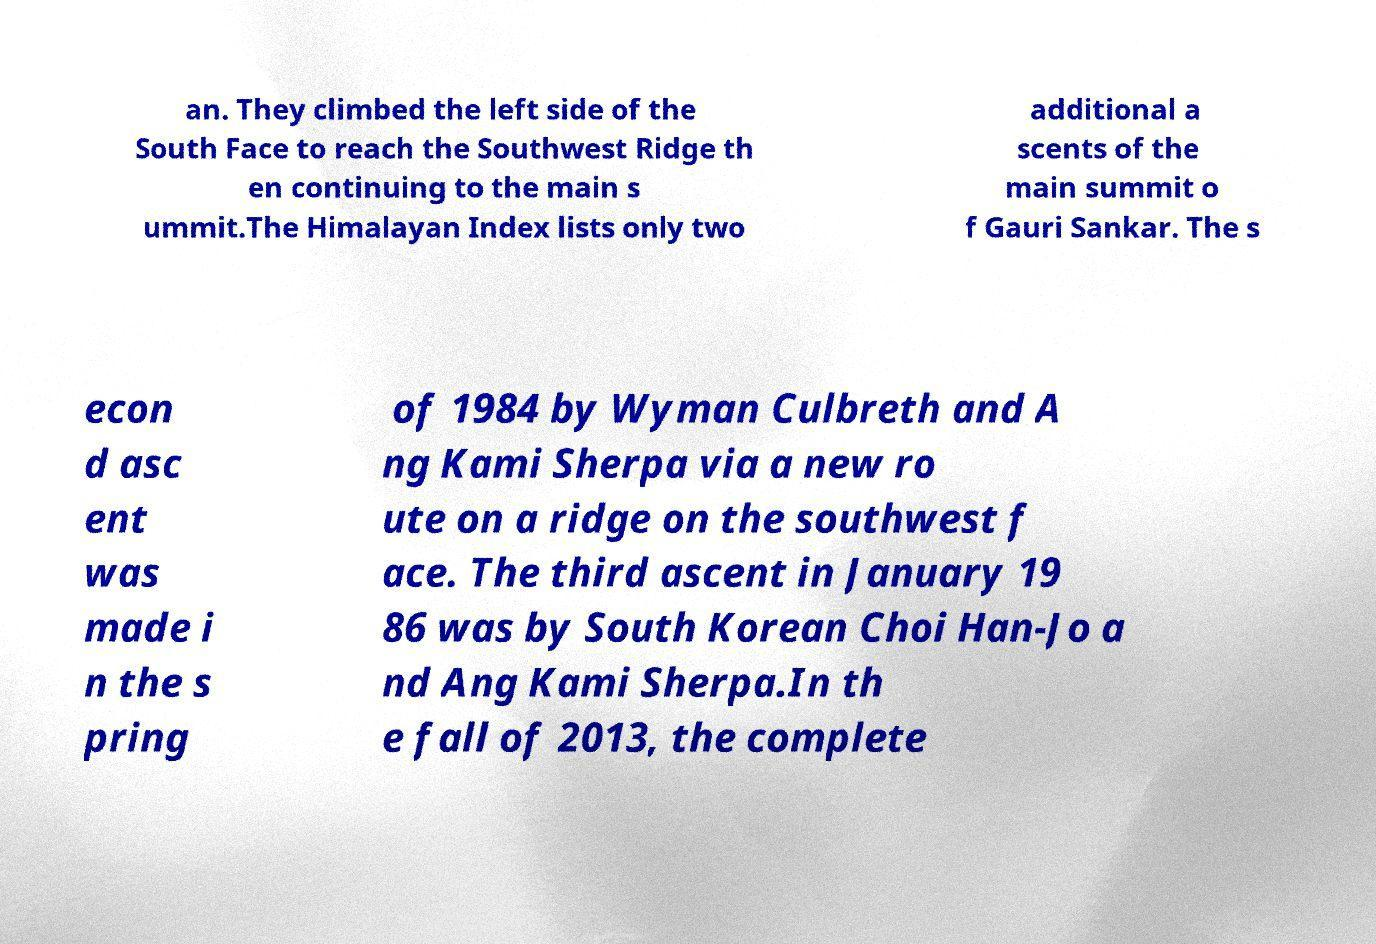Can you read and provide the text displayed in the image?This photo seems to have some interesting text. Can you extract and type it out for me? an. They climbed the left side of the South Face to reach the Southwest Ridge th en continuing to the main s ummit.The Himalayan Index lists only two additional a scents of the main summit o f Gauri Sankar. The s econ d asc ent was made i n the s pring of 1984 by Wyman Culbreth and A ng Kami Sherpa via a new ro ute on a ridge on the southwest f ace. The third ascent in January 19 86 was by South Korean Choi Han-Jo a nd Ang Kami Sherpa.In th e fall of 2013, the complete 